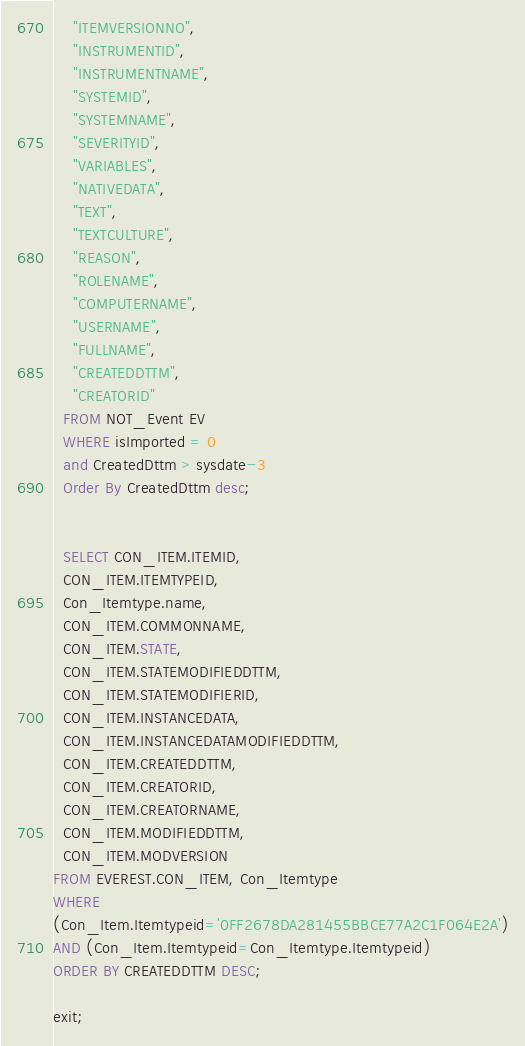<code> <loc_0><loc_0><loc_500><loc_500><_SQL_>    "ITEMVERSIONNO",
    "INSTRUMENTID",
    "INSTRUMENTNAME",
    "SYSTEMID",
    "SYSTEMNAME",
    "SEVERITYID",
    "VARIABLES",
    "NATIVEDATA",
    "TEXT",
    "TEXTCULTURE",
    "REASON",
    "ROLENAME",
    "COMPUTERNAME",
    "USERNAME",
    "FULLNAME",
    "CREATEDDTTM",
    "CREATORID"
  FROM NOT_Event EV
  WHERE isImported = 0
  and CreatedDttm > sysdate-3
  Order By CreatedDttm desc;
  
  
  SELECT CON_ITEM.ITEMID,
  CON_ITEM.ITEMTYPEID,
  Con_Itemtype.name,
  CON_ITEM.COMMONNAME,
  CON_ITEM.STATE,
  CON_ITEM.STATEMODIFIEDDTTM,
  CON_ITEM.STATEMODIFIERID,
  CON_ITEM.INSTANCEDATA,
  CON_ITEM.INSTANCEDATAMODIFIEDDTTM,
  CON_ITEM.CREATEDDTTM,
  CON_ITEM.CREATORID,
  CON_ITEM.CREATORNAME,
  CON_ITEM.MODIFIEDDTTM,
  CON_ITEM.MODVERSION
FROM EVEREST.CON_ITEM, Con_Itemtype
WHERE 
(Con_Item.Itemtypeid='0FF2678DA281455BBCE77A2C1F064E2A')
AND (Con_Item.Itemtypeid=Con_Itemtype.Itemtypeid)
ORDER BY CREATEDDTTM DESC;
  
exit;
</code> 